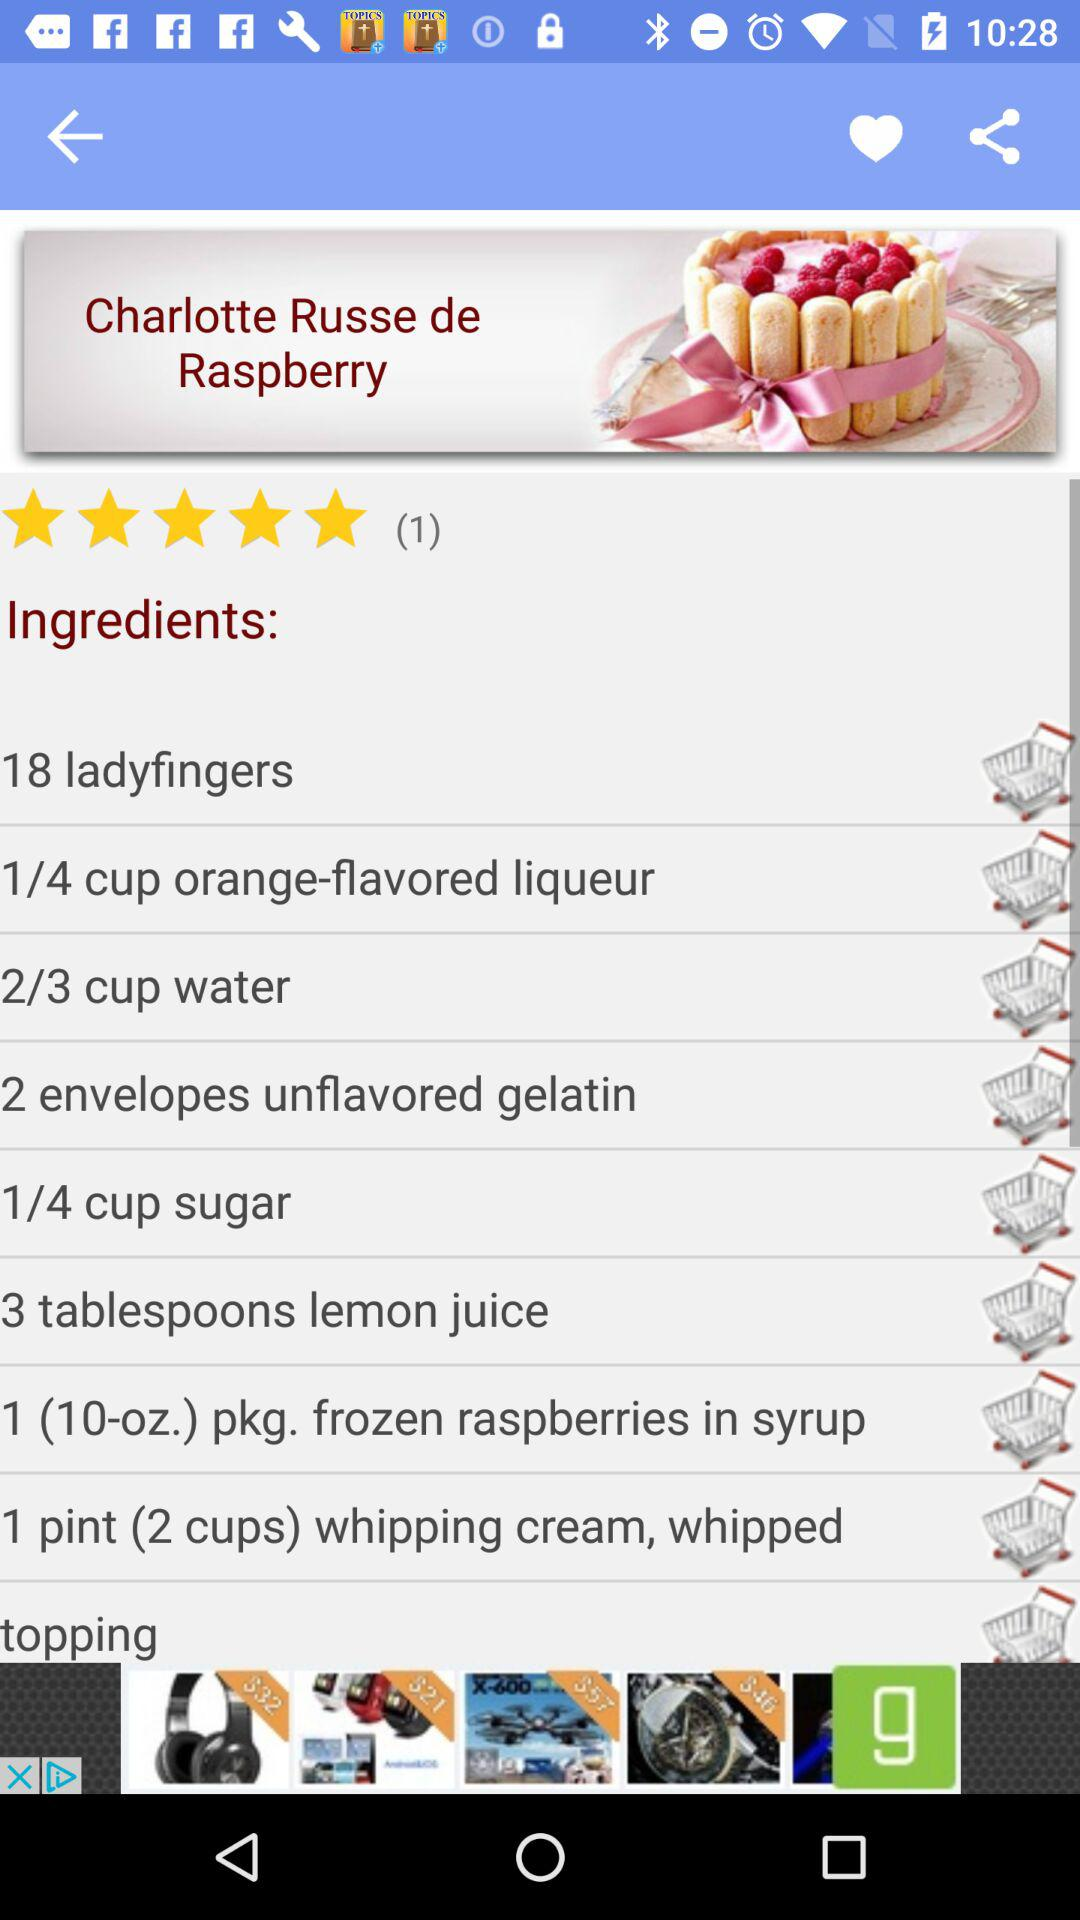How many ladyfingers are required? The required ladyfingers are 18. 